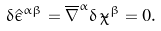<formula> <loc_0><loc_0><loc_500><loc_500>\delta \hat { \epsilon } ^ { \alpha \beta } = \overline { \nabla } ^ { \alpha } \delta \, \tilde { \chi } ^ { \beta } = 0 .</formula> 